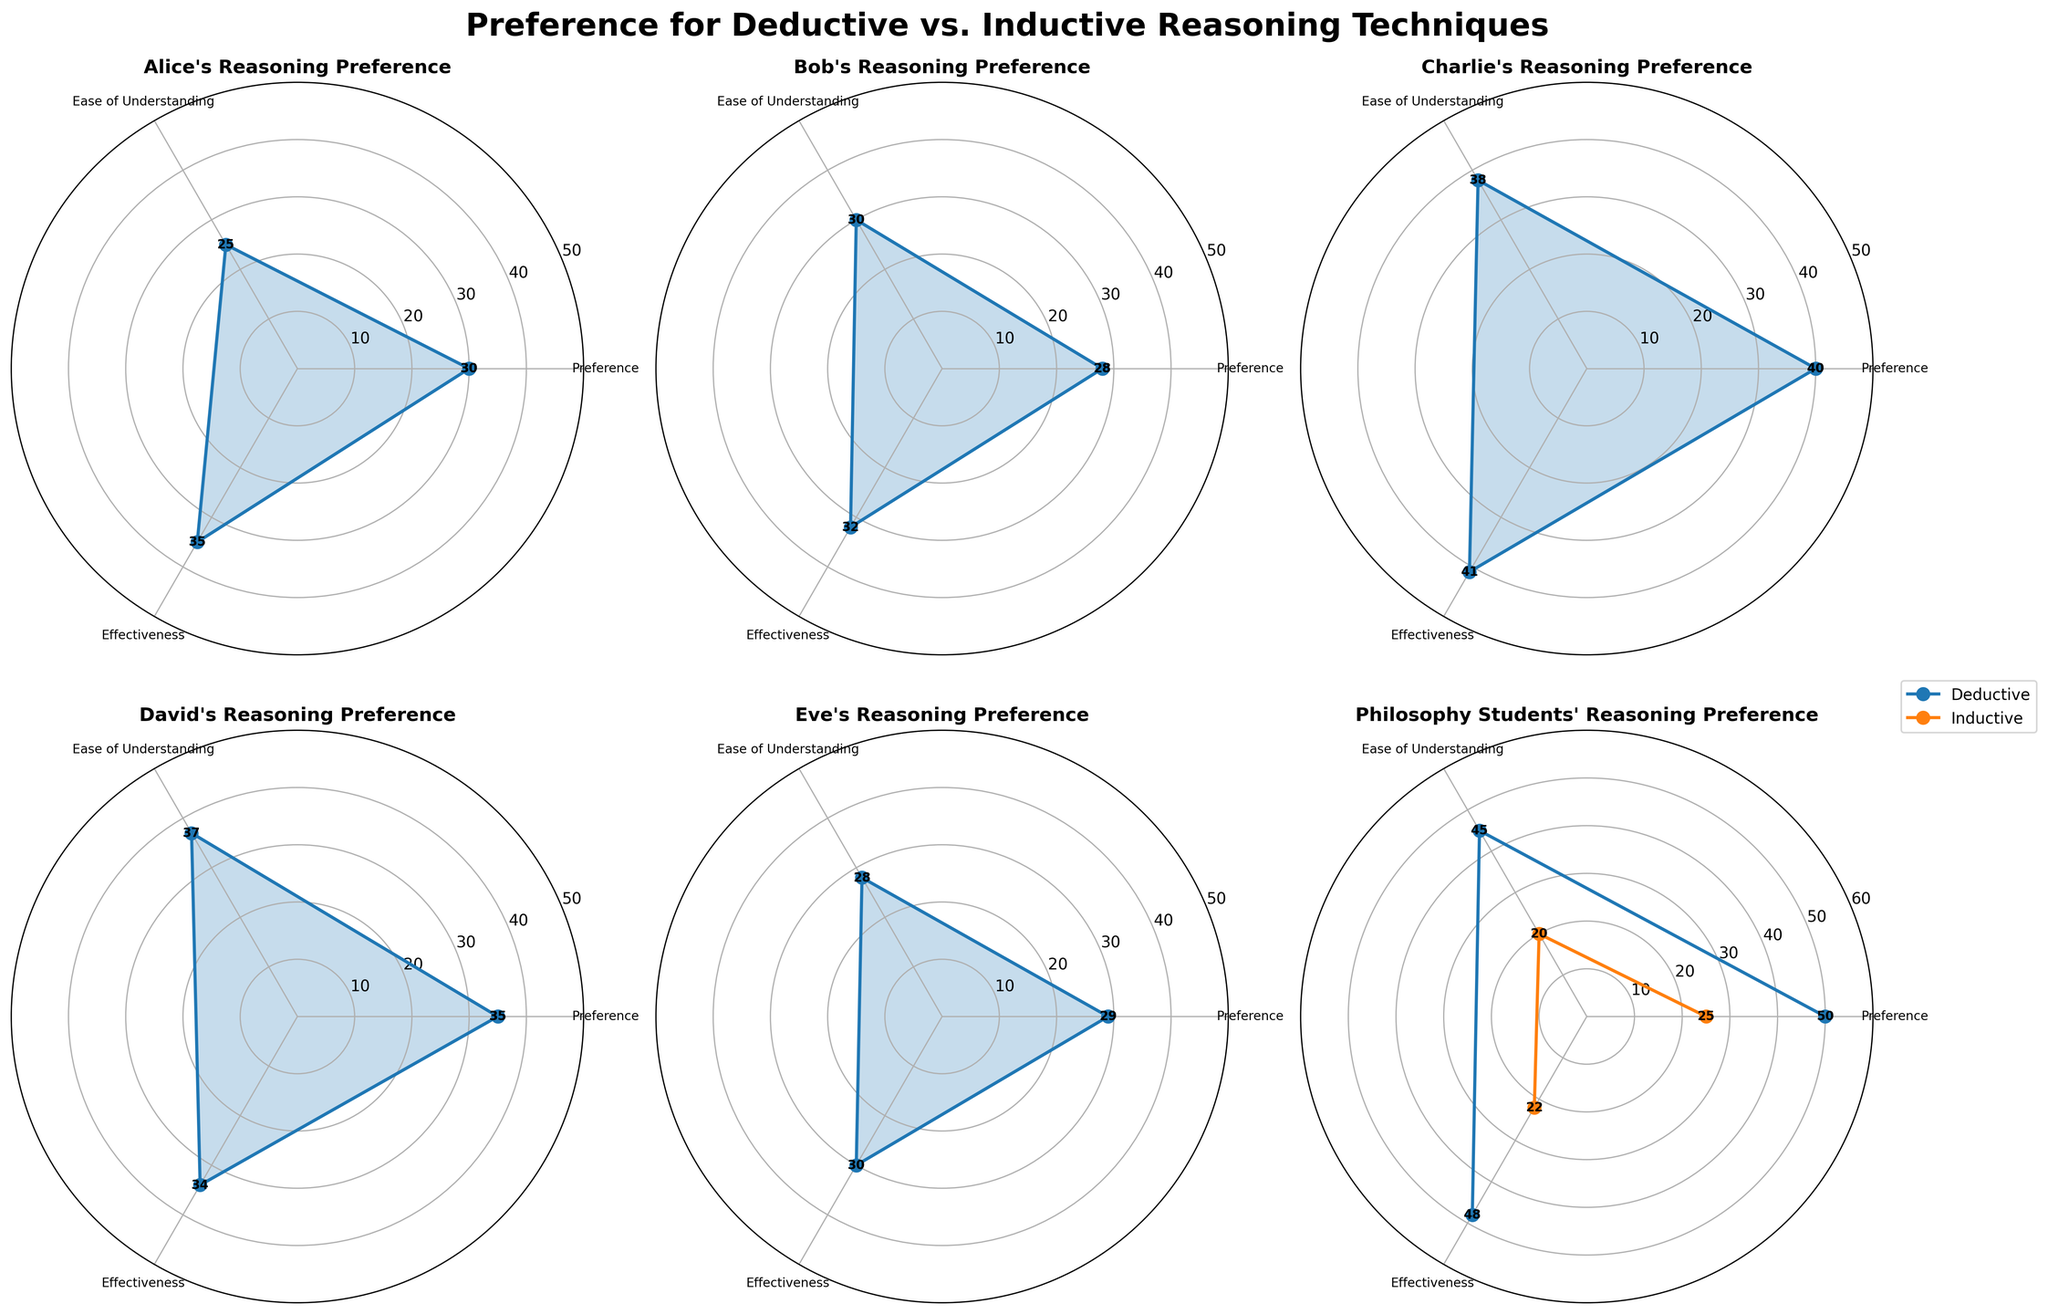What is the title of the plot? The title is visually situated at the top center of the plot and reads "Preference for Deductive vs. Inductive Reasoning Techniques".
Answer: Preference for Deductive vs. Inductive Reasoning Techniques How many categories are evaluated for each student? The plot displays three categories of evaluation for each student: Preference, Ease of Understanding, and Effectiveness. This can be inferred from the radial axes labeled on each subplot.
Answer: Three Which student has the highest value for 'Preference'? By inspecting the radial values in each subplot for the 'Preference' category, Charlie stands out with the highest value of 40.
Answer: Charlie What is the average 'Ease of Understanding' value for Eve and Alice? We sum the 'Ease of Understanding' values for both Eve (28) and Alice (25). Then, we divide by the number of students, which is 2. (28 + 25)/2 = 53/2 = 26.5
Answer: 26.5 Which categories have the largest differences in values between philosophical students' deductive and inductive reasoning preferences? Examining the Philosophy Students subplot, we can compare the paired category values. We find the largest difference in 'Ease of Understanding' where Deductive has 45 and Inductive has 20, making a difference of 25.
Answer: Ease of Understanding How does David’s 'Effectiveness' value compare with Bob’s? By comparing the 'Effectiveness' values in David’s subplot and Bob’s subplot, we see David has a value of 34 while Bob has 32. Therefore, David's value is higher.
Answer: David's is higher What is the total score across all categories for Charlie’s Deductive reasoning? For Charlie, summing the values for Deductive reasoning across all categories: 40 (Preference) + 38 (Ease of Understanding) + 41 (Effectiveness) = 119
Answer: 119 What is the difference between Alice's and David's scores for 'Ease of Understanding'? To find this, subtract Alice’s score from David’s score for 'Ease of Understanding'. That is, 37 - 25 = 12.
Answer: 12 Which student scores the lowest in 'Preference'? Inspecting the values for the 'Preference' category in each student's subplot, Alice has the lowest score with 30.
Answer: Alice 